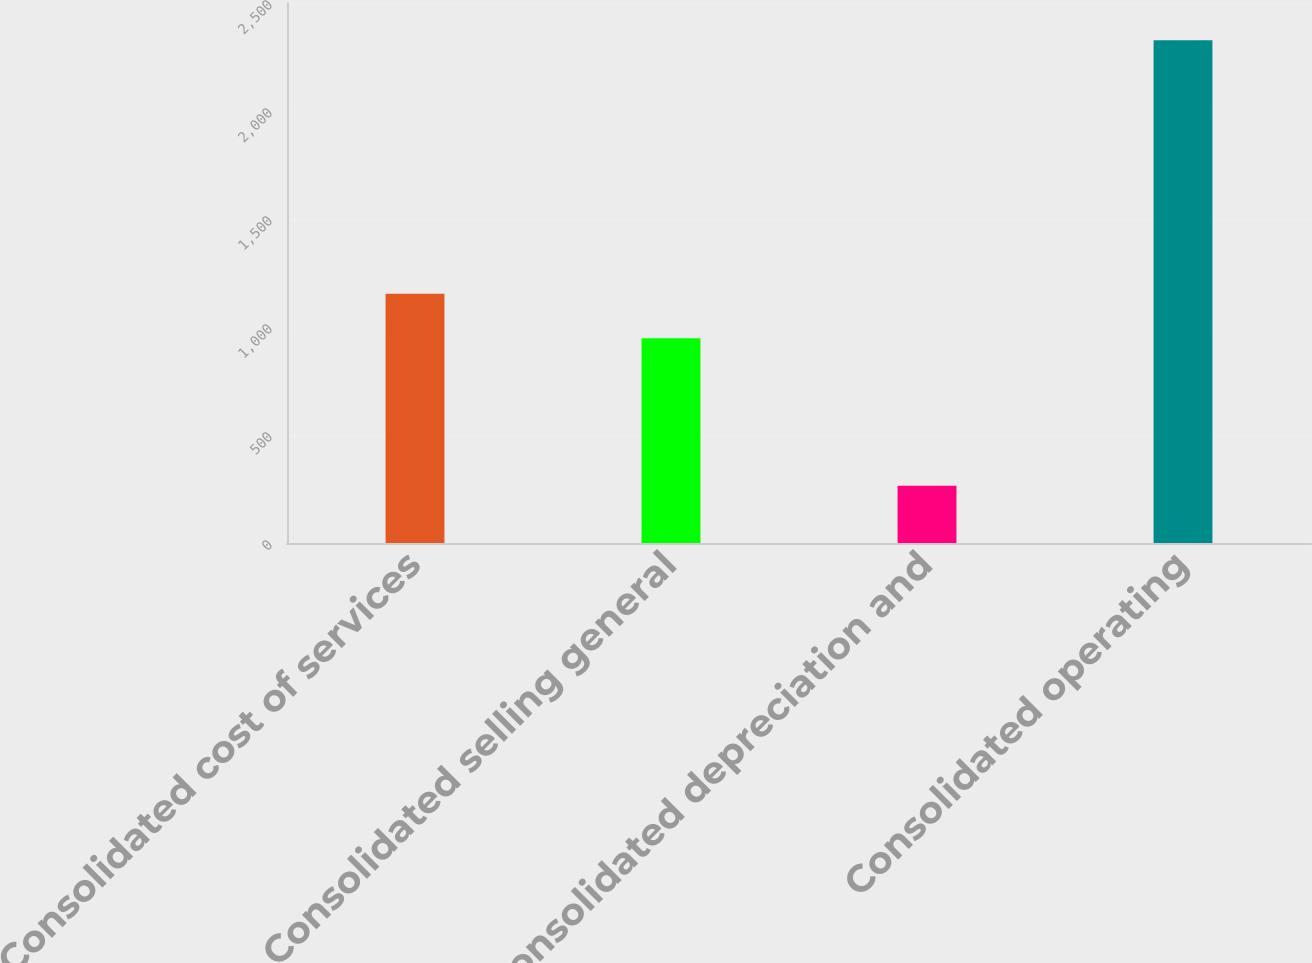Convert chart to OTSL. <chart><loc_0><loc_0><loc_500><loc_500><bar_chart><fcel>Consolidated cost of services<fcel>Consolidated selling general<fcel>Consolidated depreciation and<fcel>Consolidated operating<nl><fcel>1154.36<fcel>948.2<fcel>265.4<fcel>2327<nl></chart> 